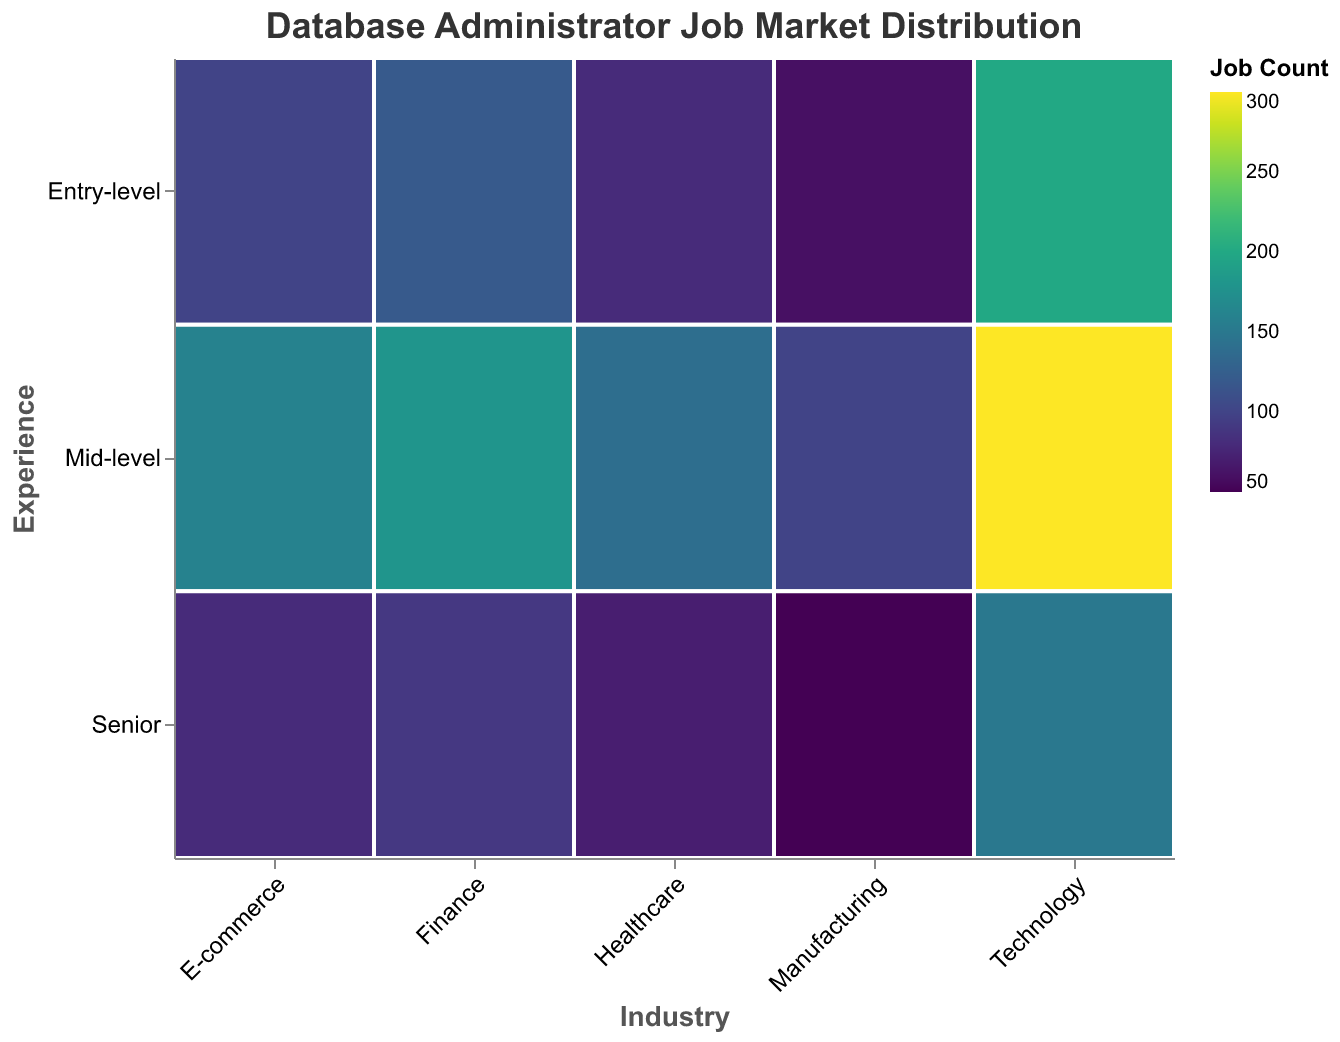What's the title of the plot? The title is displayed at the top of the plot and is "Database Administrator Job Market Distribution".
Answer: Database Administrator Job Market Distribution Which industry sector has the highest number of entry-level database administrator jobs? Look at the rectangles in the row labeled "Entry-level" to see which one is the largest. The rectangle under "Technology" is the largest for entry-level positions.
Answer: Technology How many job positions are there for senior-level database administrators in the Finance industry? Find the "Finance" column and look at the cell corresponding to "Senior" in the "Experience" row. The count is displayed using color, and it shows a value of 90.
Answer: 90 What is the total number of mid-level database administrator jobs across all industries? Sum the job counts for mid-level positions across all industries: Finance (180), Healthcare (140), Technology (300), E-commerce (160), and Manufacturing (100). The total is 180 + 140 + 300 + 160 + 100.
Answer: 880 Which industry has a higher number of senior-level positions, Healthcare or Manufacturing? Compare the senior-level cells for Healthcare and Manufacturing by looking at their corresponding counts. Healthcare has 70, while Manufacturing has 50.
Answer: Healthcare What's the difference between the number of entry-level database administrator jobs in Technology and Finance? Find the count of entry-level positions in Technology (200) and Finance (120). The difference is 200 - 120.
Answer: 80 Which industry employs the highest number of database administrators overall? Add up all job counts for each industry: Technology (200+300+150), Finance (120+180+90), Healthcare (80+140+70), E-commerce (100+160+80), and Manufacturing (60+100+50). The largest sum will reveal the answer.
Answer: Technology In which industry and experience level is the smallest number of database administrator jobs found? Identify the smallest rectangle in the plot. Senior-level positions in Manufacturing have the smallest count, which is 50.
Answer: Senior-level in Manufacturing How does the number of mid-level jobs in the E-commerce sector compare to senior-level jobs in Technology? Look at the plot and compare the count of mid-level jobs in E-commerce (160) to senior-level jobs in Technology (150).
Answer: Mid-level in E-commerce is higher What is the proportion of senior-level jobs within the Technology sector? Find the total number of jobs in Technology (200+300+150). Then, divide the number of senior-level jobs (150) by this total and multiply by 100 to get the percentage.
Answer: 23.1% 